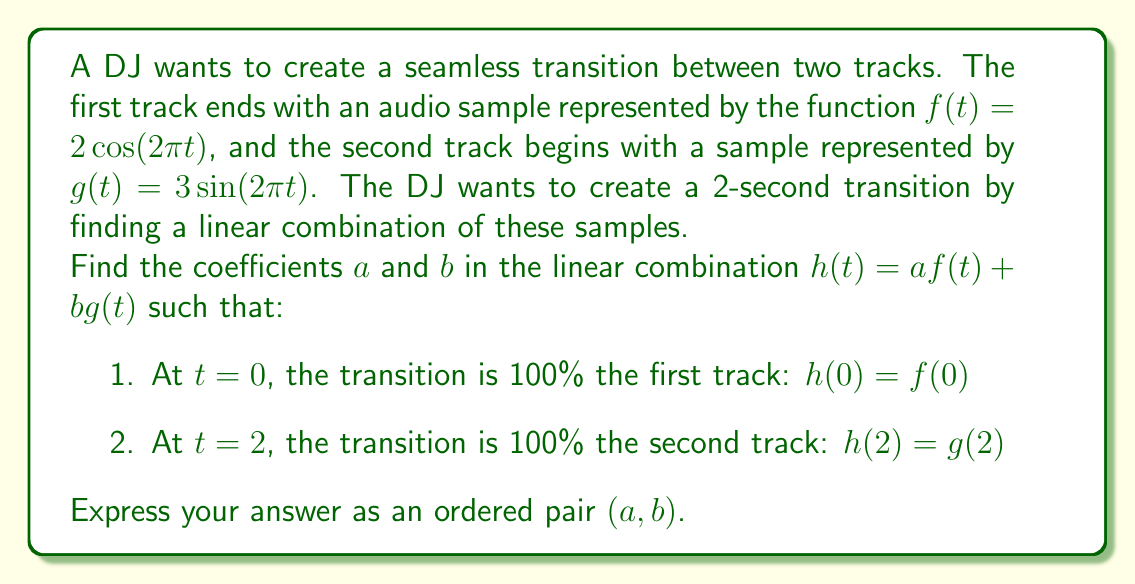Solve this math problem. Let's approach this step-by-step:

1) First, we need to evaluate $f(0)$, $f(2)$, $g(0)$, and $g(2)$:

   $f(0) = 2\cos(2\pi \cdot 0) = 2$
   $f(2) = 2\cos(2\pi \cdot 2) = 2$
   $g(0) = 3\sin(2\pi \cdot 0) = 0$
   $g(2) = 3\sin(2\pi \cdot 2) = 0$

2) Now, we can set up our equations based on the given conditions:

   At $t=0$: $h(0) = f(0)$
   $af(0) + bg(0) = f(0)$
   $a(2) + b(0) = 2$
   $2a = 2$ ... (Equation 1)

   At $t=2$: $h(2) = g(2)$
   $af(2) + bg(2) = g(2)$
   $a(2) + b(0) = 0$
   $2a = 0$ ... (Equation 2)

3) From Equation 1, we can deduce that $a = 1$.

4) From Equation 2, we can see that $a$ must be 0 to satisfy this equation.

5) The only way to satisfy both equations is if $a$ changes from 1 to 0 over the course of the transition. We can represent this with a linear function:

   $a(t) = 1 - \frac{t}{2}$

6) To maintain the total amplitude, $b$ should increase as $a$ decreases:

   $b(t) = \frac{t}{2}$

7) Therefore, our transition function is:

   $h(t) = (1-\frac{t}{2})f(t) + (\frac{t}{2})g(t)$

This satisfies both conditions:
At $t=0$: $h(0) = (1-0)f(0) + (0)g(0) = f(0)$
At $t=2$: $h(2) = (0)f(2) + (1)g(2) = g(2)$
Answer: The coefficients $a$ and $b$ are functions of time:
$a(t) = 1 - \frac{t}{2}$, $b(t) = \frac{t}{2}$ 